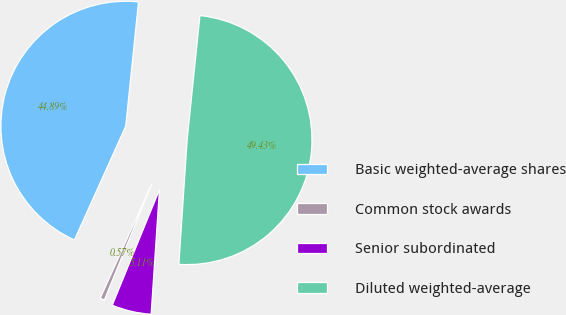Convert chart to OTSL. <chart><loc_0><loc_0><loc_500><loc_500><pie_chart><fcel>Basic weighted-average shares<fcel>Common stock awards<fcel>Senior subordinated<fcel>Diluted weighted-average<nl><fcel>44.89%<fcel>0.57%<fcel>5.11%<fcel>49.43%<nl></chart> 